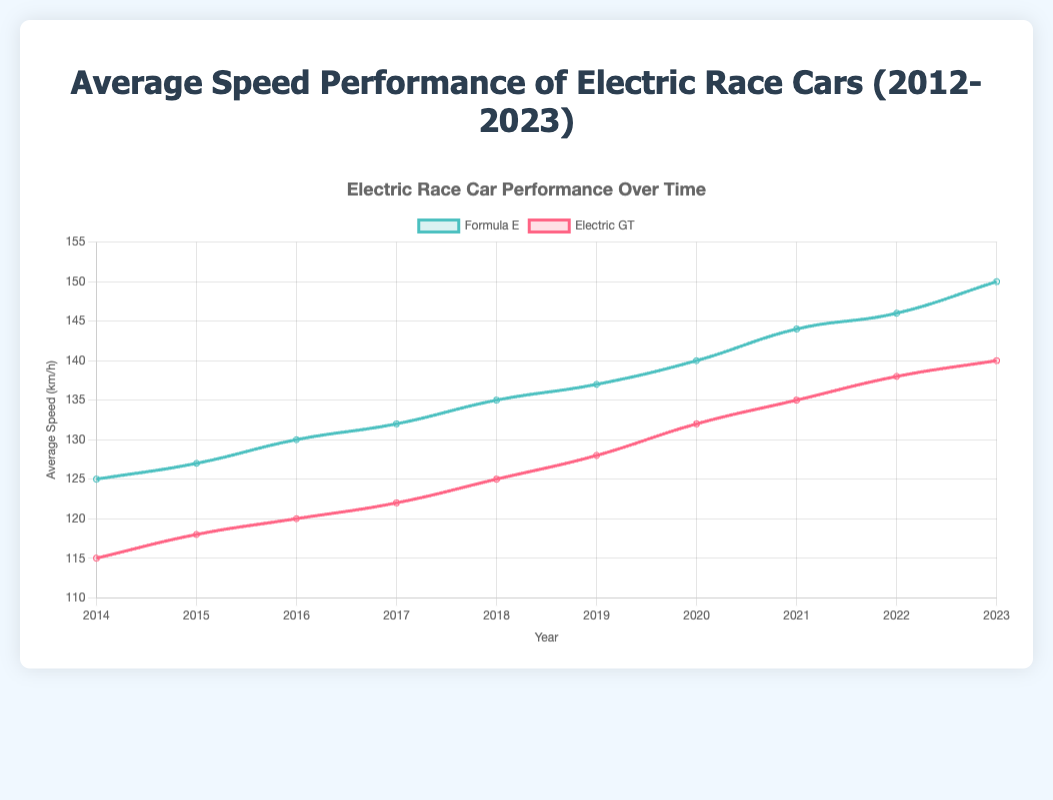What is the average speed of Electric GT in 2020? The line for Electric GT corresponding to the year 2020 shows an average speed value. This value is 138 km/h.
Answer: 138 km/h How many years does it take for Formula E to increase its average speed from 125 km/h to 150 km/h? Formula E's average speed in 2014 is 125 km/h, and it reaches 150 km/h in 2023. The difference in years is 2023 - 2014 = 9 years.
Answer: 9 years Which series had a higher average speed in 2016, Formula E or Electric GT? In the year 2016, Formula E had an average speed of 130 km/h, and Electric GT had an average speed of 125 km/h. Since 130 km/h is greater than 125 km/h, Formula E had a higher average speed in that year.
Answer: Formula E Between which years did Electric GT see the largest increase in average speed? Examine the increments between each year for Electric GT. The largest increase is between 2017 and 2018, where the average speed increased from 128 km/h to 132 km/h, which is an increase of 4 km/h.
Answer: 2017-2018 By how much did the average speed of Formula E increase from 2018 to 2023? The average speed of Formula E in 2018 is 135 km/h and in 2023 it is 150 km/h. The increase is 150 km/h - 135 km/h = 15 km/h.
Answer: 15 km/h Was there any year where both Formula E and Electric GT had the same average speed? Compare the values for each year. In 2014, both Formula E and Electric GT had an average speed of 125 km/h.
Answer: 2014 What's the total increase in average speed for Electric GT from 2012 to 2023? The average speed for Electric GT in 2012 is 115 km/h and in 2023 is 145 km/h. The total increase is 145 km/h - 115 km/h = 30 km/h.
Answer: 30 km/h What is the color used to represent Formula E in the chart? Look at the color used for the line representing Formula E, which is green.
Answer: Green In which year did Electric GT reach an average speed of 140 km/h? The Electric GT line hitting 140 km/h occurs in the year 2021.
Answer: 2021 Which series showed a more consistent yearly increase in average speed from 2012 to 2023? To determine consistency, analyze the trends. Both show increases, but Formula E show slightly more consistent increments year-over-year compared to the faster increments of Electric GT post-2017.
Answer: Formula E 